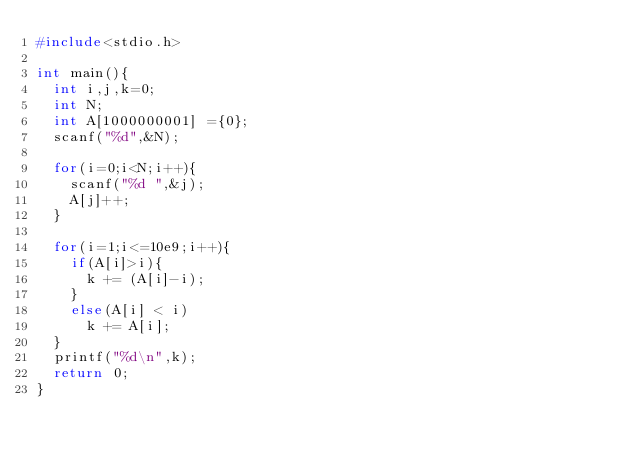<code> <loc_0><loc_0><loc_500><loc_500><_C_>#include<stdio.h>

int main(){
  int i,j,k=0;
  int N;
  int A[1000000001] ={0};
  scanf("%d",&N);
  
  for(i=0;i<N;i++){
    scanf("%d ",&j);
    A[j]++;
  }
  
  for(i=1;i<=10e9;i++){
    if(A[i]>i){
      k += (A[i]-i);
    }
    else(A[i] < i)
      k += A[i];
  }
  printf("%d\n",k);
  return 0;
}</code> 